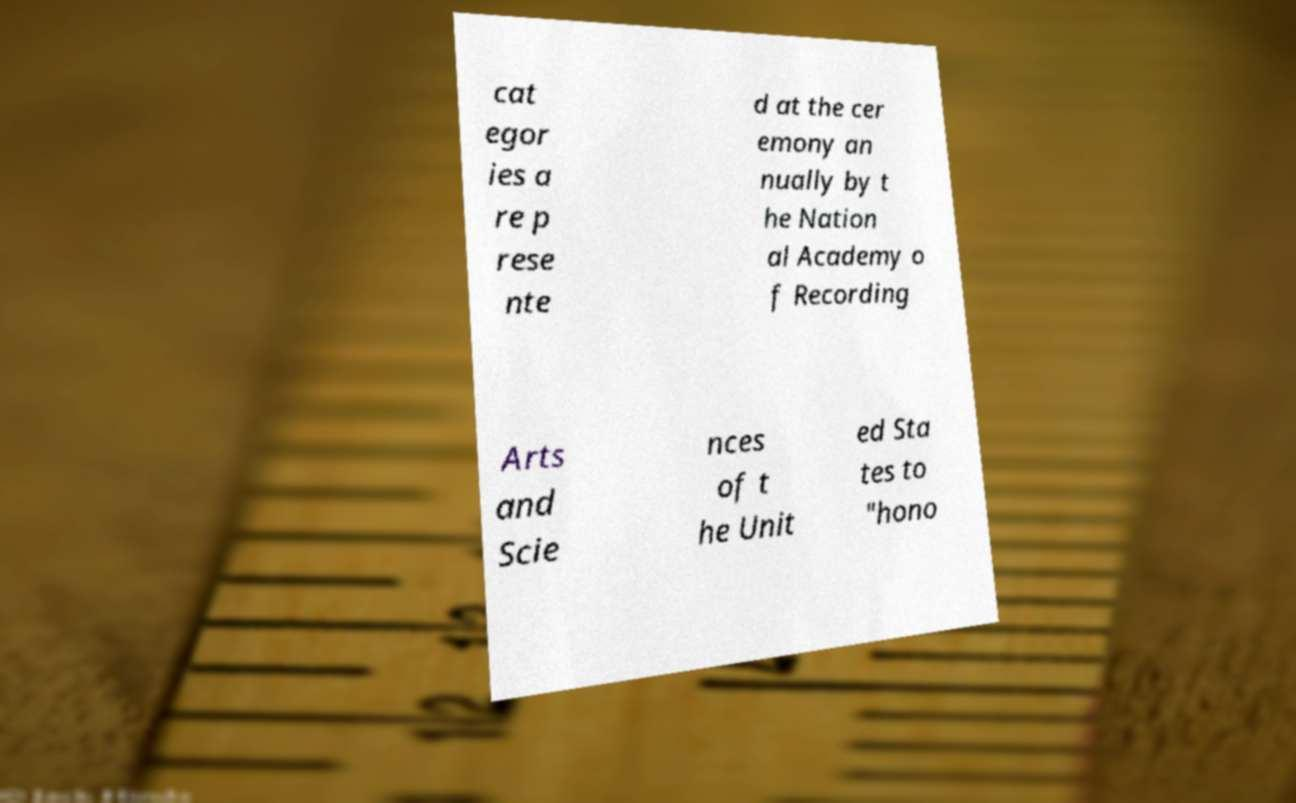Could you extract and type out the text from this image? cat egor ies a re p rese nte d at the cer emony an nually by t he Nation al Academy o f Recording Arts and Scie nces of t he Unit ed Sta tes to "hono 